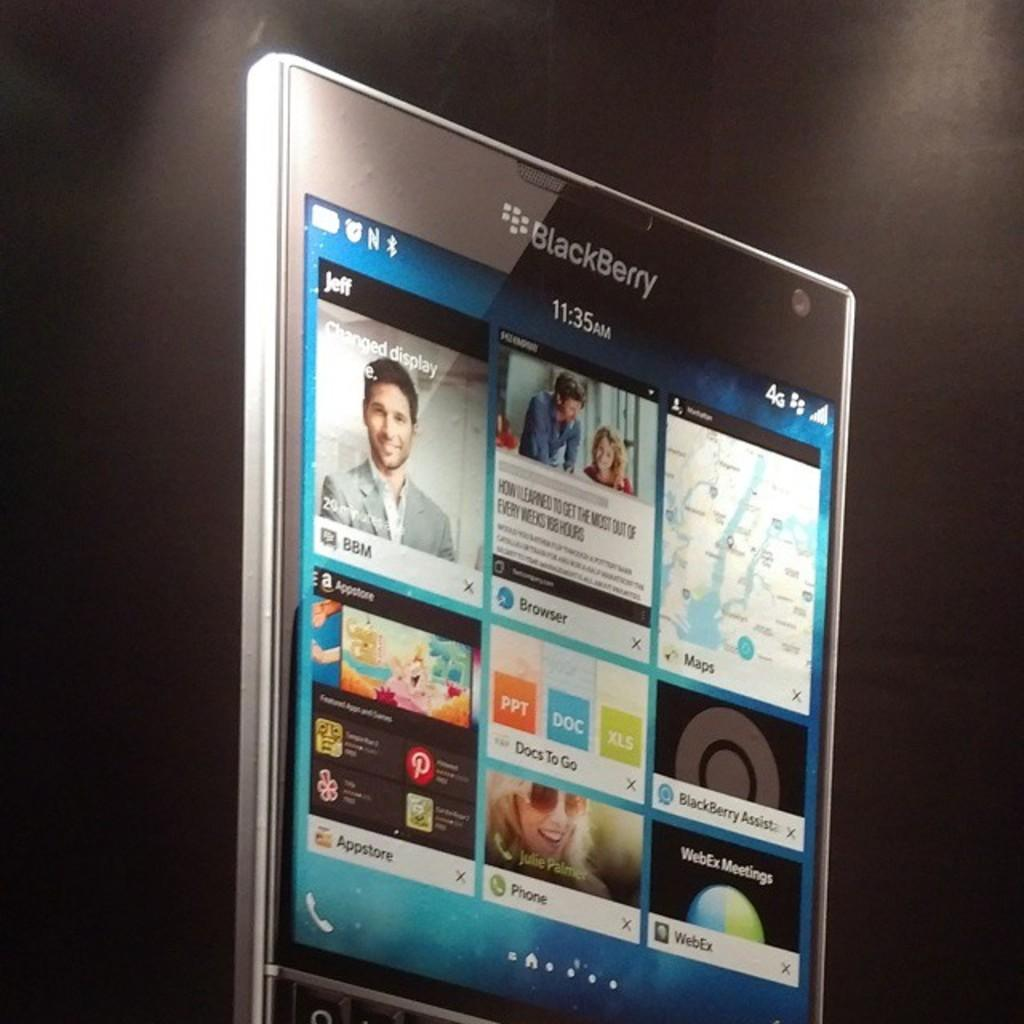<image>
Share a concise interpretation of the image provided. a Blackberry phone with many images on it 